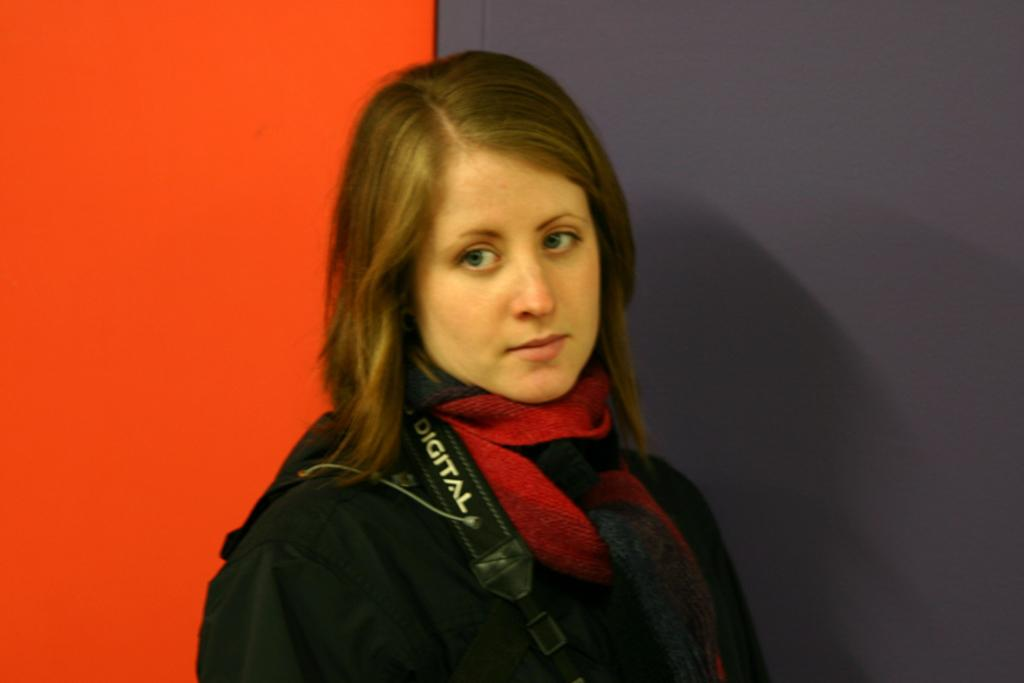Who is the main subject in the image? There is a woman in the center of the image. What is the woman wearing? The woman is wearing a camera. What color is the wall on the left side of the image? The wall on the left side of the image is red. What type of copper material can be seen on the woman's camera in the image? There is no mention of copper material in the image; the woman is simply wearing a camera. How many women are present in the image? There is only one woman present in the image. 